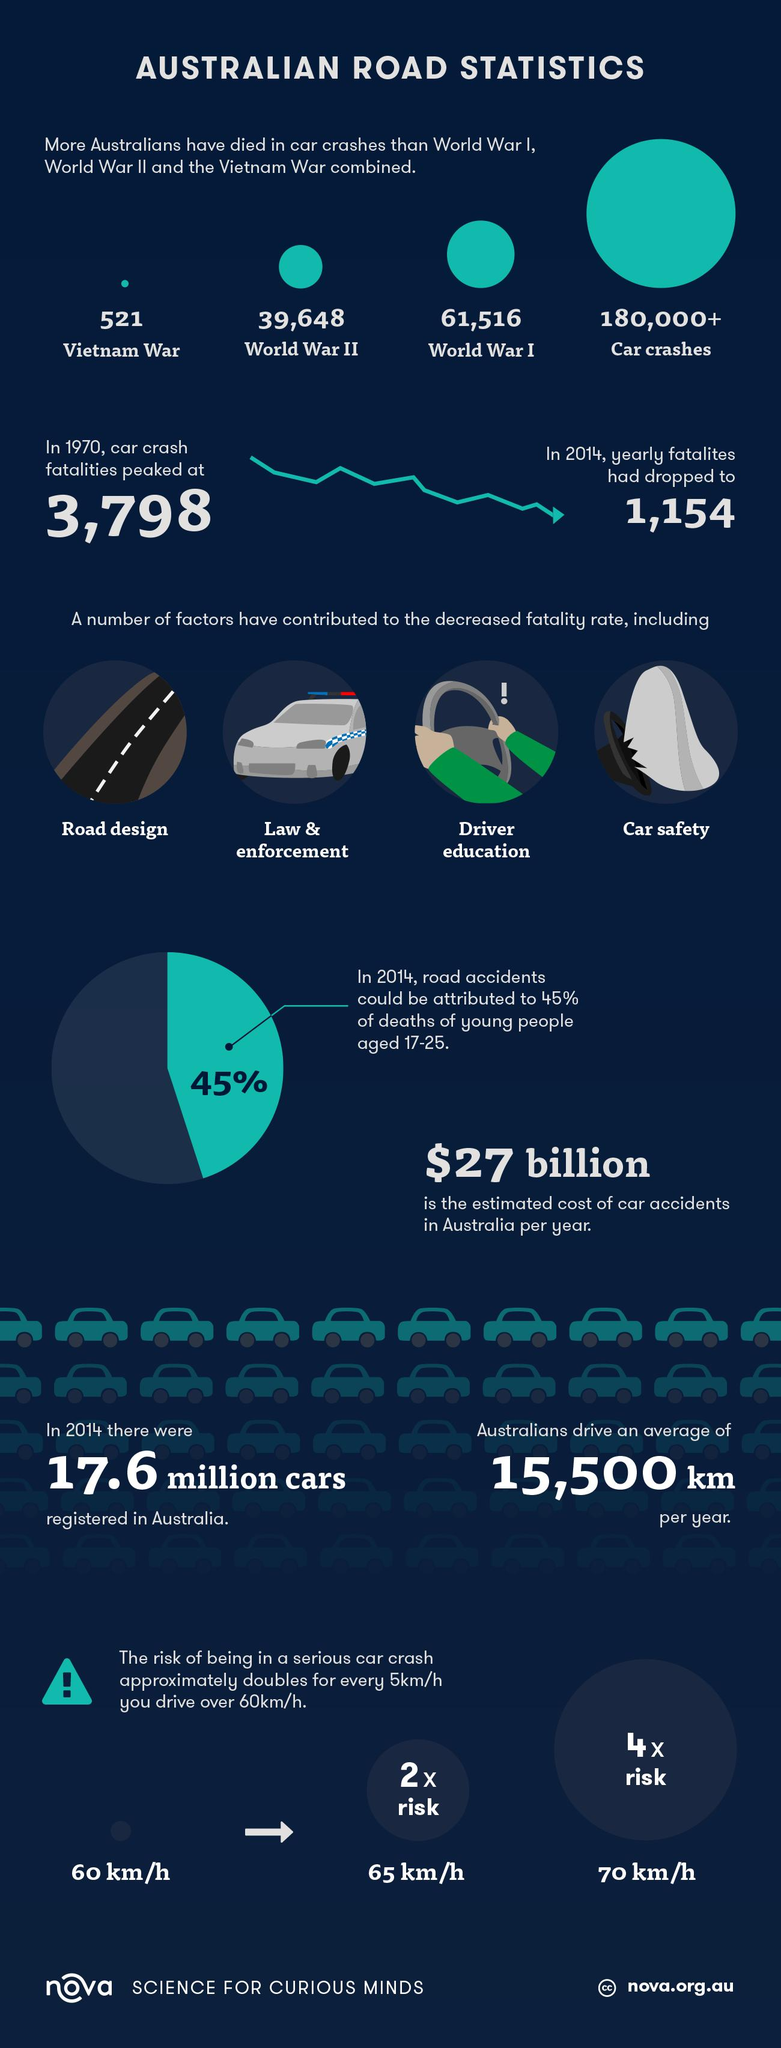Give some essential details in this illustration. The color of the shirt sleeve is green, not red. In 1970, there were 2644 more crash fatalities than in 2014. The risk of a serious car crash increases significantly at a speed of 70 km/h, as compared to driving at a slower speed. In fact, research has shown that for every additional 10 km/h over the speed limit, the risk of a crash increases by four times. Therefore, it is important to drive at a safe speed and obey traffic laws to reduce the risk of a serious car accident. The peak of car crashes occurred in 1970. According to the document, a safe speed is considered to be 60 km/h. 